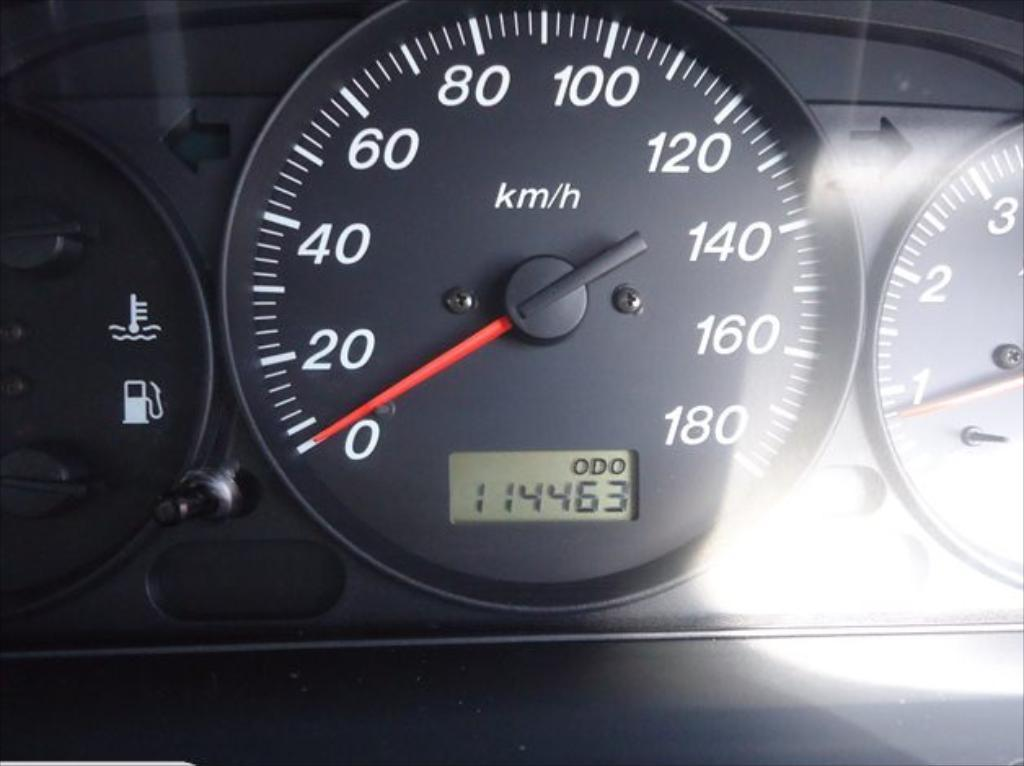What is the main object in the image? There is a speedometer in the image. What color is the needle on the speedometer? The speedometer has a red color needle. What can be used to measure speed on the speedometer? There are numbers on the speedometer. What is the color of the speedometer itself? The speedometer is in black color. Can you see a cart being pushed on the floor in the image? There is no cart or floor present in the image; it only features a speedometer. 